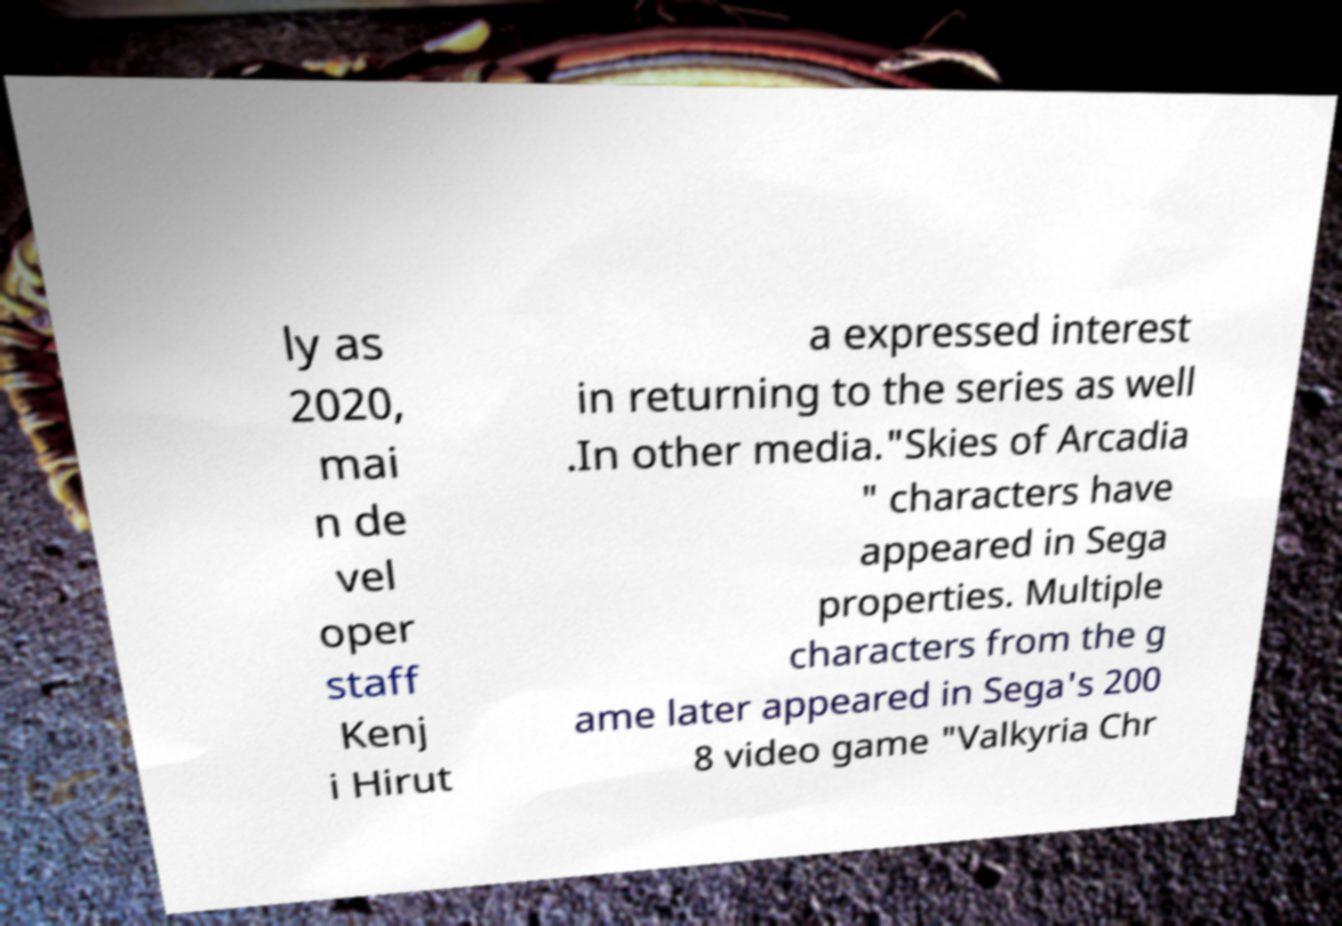Please read and relay the text visible in this image. What does it say? ly as 2020, mai n de vel oper staff Kenj i Hirut a expressed interest in returning to the series as well .In other media."Skies of Arcadia " characters have appeared in Sega properties. Multiple characters from the g ame later appeared in Sega's 200 8 video game "Valkyria Chr 